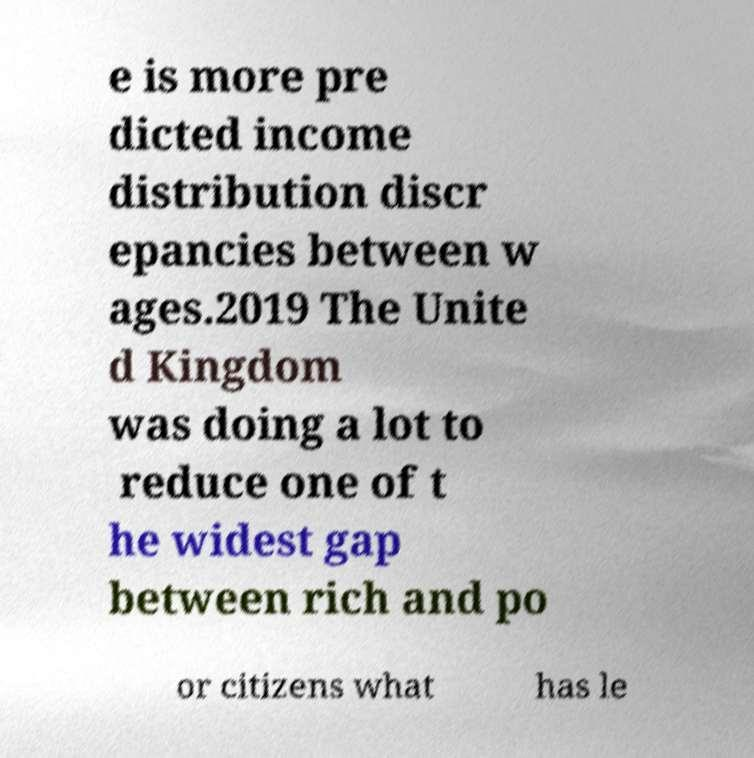Can you accurately transcribe the text from the provided image for me? e is more pre dicted income distribution discr epancies between w ages.2019 The Unite d Kingdom was doing a lot to reduce one of t he widest gap between rich and po or citizens what has le 